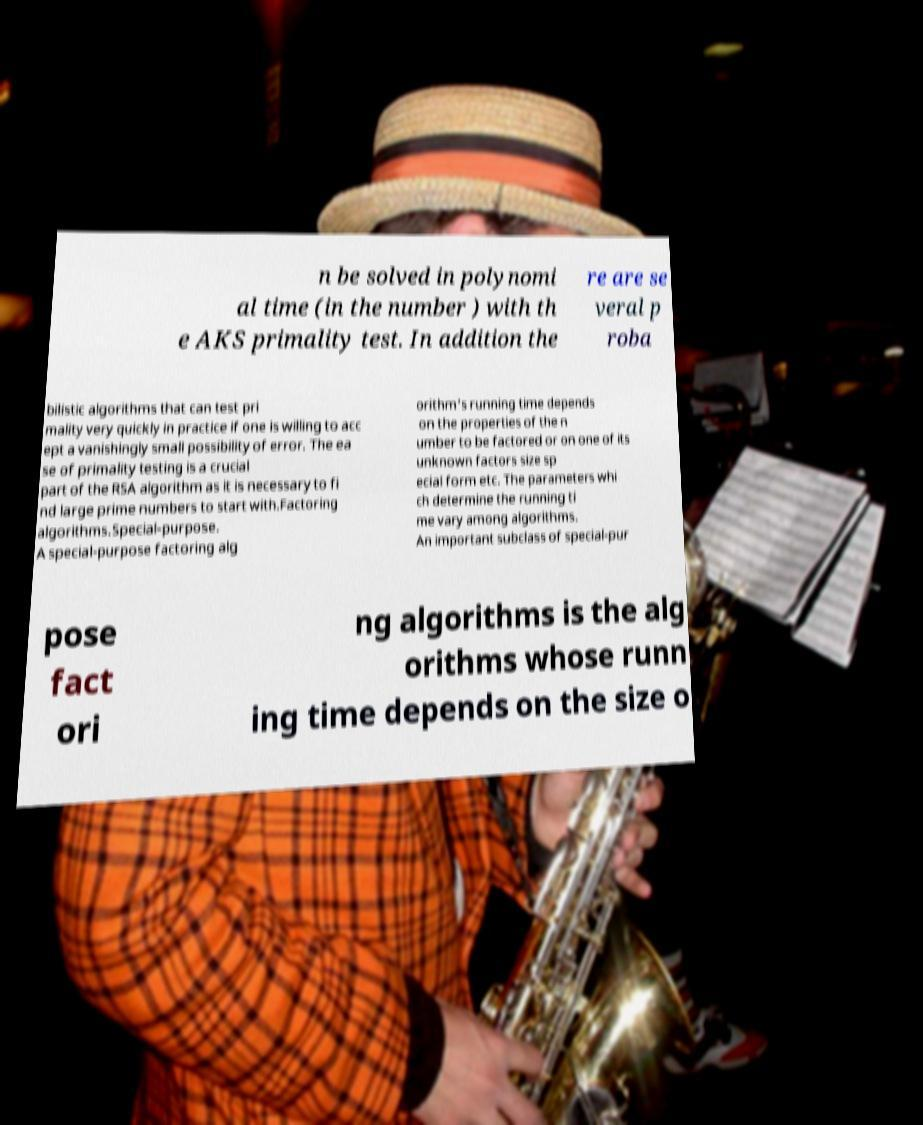Please read and relay the text visible in this image. What does it say? n be solved in polynomi al time (in the number ) with th e AKS primality test. In addition the re are se veral p roba bilistic algorithms that can test pri mality very quickly in practice if one is willing to acc ept a vanishingly small possibility of error. The ea se of primality testing is a crucial part of the RSA algorithm as it is necessary to fi nd large prime numbers to start with.Factoring algorithms.Special-purpose. A special-purpose factoring alg orithm's running time depends on the properties of the n umber to be factored or on one of its unknown factors size sp ecial form etc. The parameters whi ch determine the running ti me vary among algorithms. An important subclass of special-pur pose fact ori ng algorithms is the alg orithms whose runn ing time depends on the size o 